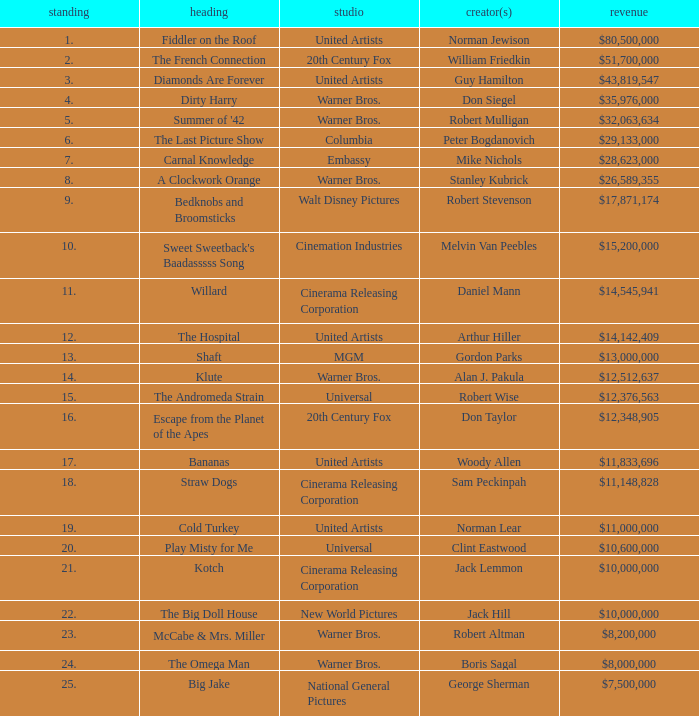What is the rank of The Big Doll House? 22.0. 